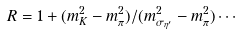<formula> <loc_0><loc_0><loc_500><loc_500>R = 1 + ( m ^ { 2 } _ { K } - m ^ { 2 } _ { \pi } ) / ( m ^ { 2 } _ { \sigma _ { \eta ^ { \prime } } } - m ^ { 2 } _ { \pi } ) \cdots</formula> 